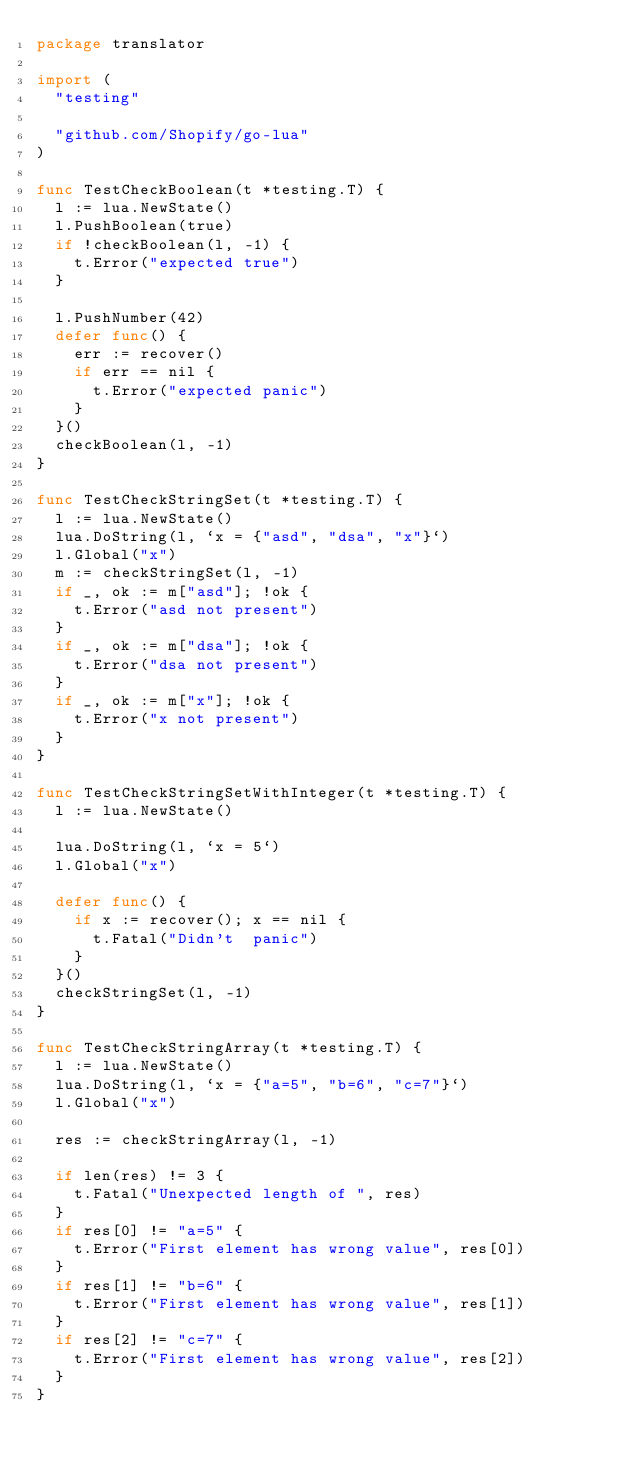Convert code to text. <code><loc_0><loc_0><loc_500><loc_500><_Go_>package translator

import (
	"testing"

	"github.com/Shopify/go-lua"
)

func TestCheckBoolean(t *testing.T) {
	l := lua.NewState()
	l.PushBoolean(true)
	if !checkBoolean(l, -1) {
		t.Error("expected true")
	}

	l.PushNumber(42)
	defer func() {
		err := recover()
		if err == nil {
			t.Error("expected panic")
		}
	}()
	checkBoolean(l, -1)
}

func TestCheckStringSet(t *testing.T) {
	l := lua.NewState()
	lua.DoString(l, `x = {"asd", "dsa", "x"}`)
	l.Global("x")
	m := checkStringSet(l, -1)
	if _, ok := m["asd"]; !ok {
		t.Error("asd not present")
	}
	if _, ok := m["dsa"]; !ok {
		t.Error("dsa not present")
	}
	if _, ok := m["x"]; !ok {
		t.Error("x not present")
	}
}

func TestCheckStringSetWithInteger(t *testing.T) {
	l := lua.NewState()

	lua.DoString(l, `x = 5`)
	l.Global("x")

	defer func() {
		if x := recover(); x == nil {
			t.Fatal("Didn't  panic")
		}
	}()
	checkStringSet(l, -1)
}

func TestCheckStringArray(t *testing.T) {
	l := lua.NewState()
	lua.DoString(l, `x = {"a=5", "b=6", "c=7"}`)
	l.Global("x")

	res := checkStringArray(l, -1)

	if len(res) != 3 {
		t.Fatal("Unexpected length of ", res)
	}
	if res[0] != "a=5" {
		t.Error("First element has wrong value", res[0])
	}
	if res[1] != "b=6" {
		t.Error("First element has wrong value", res[1])
	}
	if res[2] != "c=7" {
		t.Error("First element has wrong value", res[2])
	}
}
</code> 